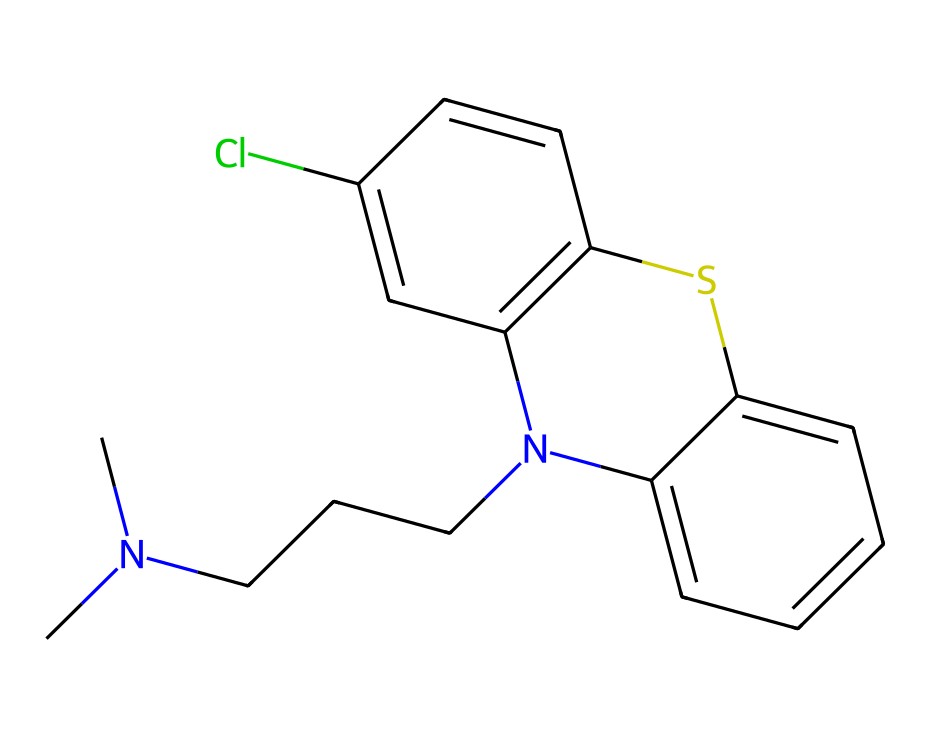What is the name of this chemical? The chemical is identified by its SMILES representation, which corresponds to Chlorpromazine, a well-known antipsychotic drug primarily used to treat schizophrenia and other psychiatric disorders.
Answer: Chlorpromazine How many nitrogen atoms are in the structure? By examining the SMILES representation and the rendered structure, I can see there are two nitrogen atoms present (one in the amine group and another in the heterocyclic ring).
Answer: two What type of chemical is Chlorpromazine? Chlorpromazine is categorized as a phenothiazine derivative, which is a type of antipsychotic or neuroleptic drug commonly prescribed for mental health conditions.
Answer: antipsychotic What functional groups are present in the chemical? Analyzing the structure, I identify a tertiary amine and a thiazine ring as functional groups in Chlorpromazine. The tertiary amine is responsible for binding in the body, while the thiazine contributes to its pharmacological activity.
Answer: tertiary amine and thiazine What is the molecular weight of Chlorpromazine? The molecular weight can be calculated using the atomic weights of constituent elements from the chemical structure. For this compound, the calculation yields a molecular weight of approximately 318.88 g/mol.
Answer: 318.88 g/mol What is the chlorine substitution in this chemical? The chlorine atom is indicated in the SMILES and can be located on the aromatic ring, contributing to the compound's overall pharmacological activities and its interaction with biological targets.
Answer: on the aromatic ring How many rings are present in the structure of Chlorpromazine? Upon reviewing the SMILES representation, it is evident that there are two ring structures: one is a part of the phenothiazine moiety and the other is an aromatic ring structure connected to the thiazine.
Answer: two 